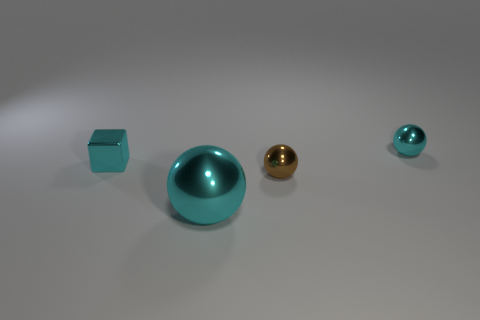Subtract 1 balls. How many balls are left? 2 Add 4 tiny yellow metallic blocks. How many objects exist? 8 Subtract all spheres. How many objects are left? 1 Add 1 matte cylinders. How many matte cylinders exist? 1 Subtract 1 brown balls. How many objects are left? 3 Subtract all cyan spheres. Subtract all brown spheres. How many objects are left? 1 Add 3 small cyan shiny cubes. How many small cyan shiny cubes are left? 4 